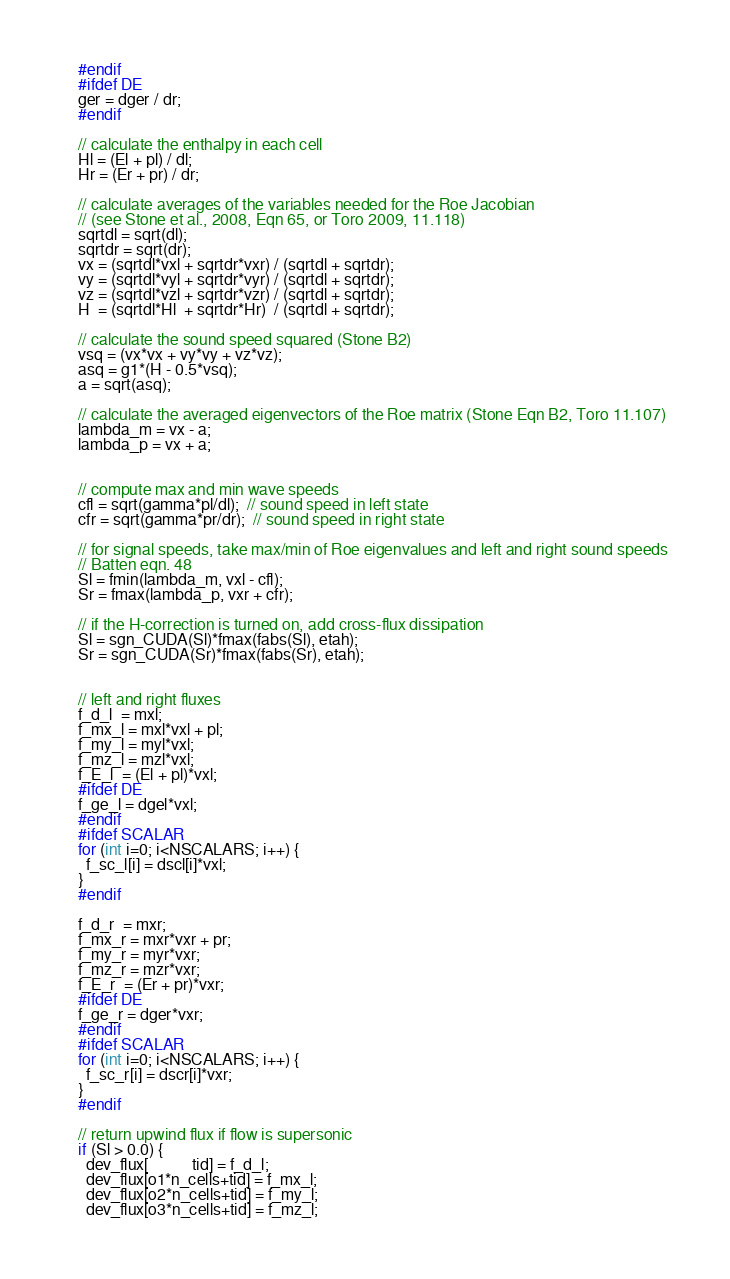<code> <loc_0><loc_0><loc_500><loc_500><_Cuda_>    #endif
    #ifdef DE
    ger = dger / dr;
    #endif

    // calculate the enthalpy in each cell
    Hl = (El + pl) / dl;
    Hr = (Er + pr) / dr;

    // calculate averages of the variables needed for the Roe Jacobian 
    // (see Stone et al., 2008, Eqn 65, or Toro 2009, 11.118)
    sqrtdl = sqrt(dl);
    sqrtdr = sqrt(dr);
    vx = (sqrtdl*vxl + sqrtdr*vxr) / (sqrtdl + sqrtdr);
    vy = (sqrtdl*vyl + sqrtdr*vyr) / (sqrtdl + sqrtdr);
    vz = (sqrtdl*vzl + sqrtdr*vzr) / (sqrtdl + sqrtdr);
    H  = (sqrtdl*Hl  + sqrtdr*Hr)  / (sqrtdl + sqrtdr); 

    // calculate the sound speed squared (Stone B2)
    vsq = (vx*vx + vy*vy + vz*vz);
    asq = g1*(H - 0.5*vsq);
    a = sqrt(asq);

    // calculate the averaged eigenvectors of the Roe matrix (Stone Eqn B2, Toro 11.107)
    lambda_m = vx - a; 
    lambda_p = vx + a;


    // compute max and min wave speeds
    cfl = sqrt(gamma*pl/dl);  // sound speed in left state
    cfr = sqrt(gamma*pr/dr);  // sound speed in right state

    // for signal speeds, take max/min of Roe eigenvalues and left and right sound speeds
    // Batten eqn. 48
    Sl = fmin(lambda_m, vxl - cfl);
    Sr = fmax(lambda_p, vxr + cfr);

    // if the H-correction is turned on, add cross-flux dissipation
    Sl = sgn_CUDA(Sl)*fmax(fabs(Sl), etah);
    Sr = sgn_CUDA(Sr)*fmax(fabs(Sr), etah);

 
    // left and right fluxes 
    f_d_l  = mxl;
    f_mx_l = mxl*vxl + pl;
    f_my_l = myl*vxl;
    f_mz_l = mzl*vxl;
    f_E_l  = (El + pl)*vxl;
    #ifdef DE
    f_ge_l = dgel*vxl;
    #endif
    #ifdef SCALAR
    for (int i=0; i<NSCALARS; i++) {
      f_sc_l[i] = dscl[i]*vxl;
    }
    #endif

    f_d_r  = mxr;
    f_mx_r = mxr*vxr + pr;
    f_my_r = myr*vxr;
    f_mz_r = mzr*vxr;
    f_E_r  = (Er + pr)*vxr;
    #ifdef DE
    f_ge_r = dger*vxr;
    #endif
    #ifdef SCALAR
    for (int i=0; i<NSCALARS; i++) {
      f_sc_r[i] = dscr[i]*vxr;
    }
    #endif

    // return upwind flux if flow is supersonic 
    if (Sl > 0.0) {
      dev_flux[           tid] = f_d_l;
      dev_flux[o1*n_cells+tid] = f_mx_l;
      dev_flux[o2*n_cells+tid] = f_my_l;
      dev_flux[o3*n_cells+tid] = f_mz_l;</code> 